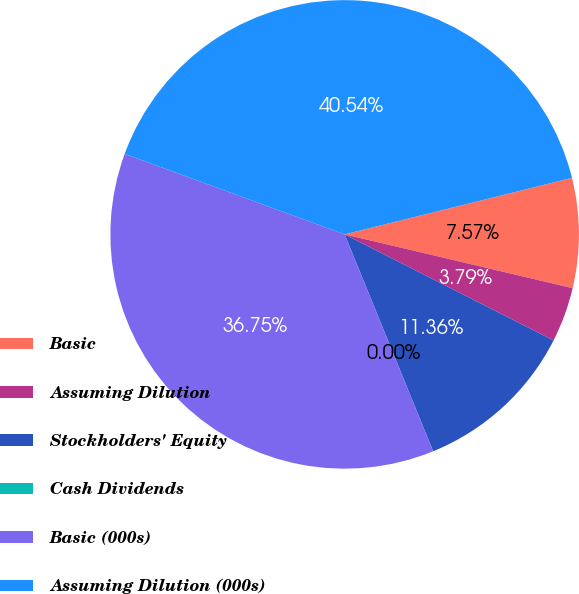Convert chart to OTSL. <chart><loc_0><loc_0><loc_500><loc_500><pie_chart><fcel>Basic<fcel>Assuming Dilution<fcel>Stockholders' Equity<fcel>Cash Dividends<fcel>Basic (000s)<fcel>Assuming Dilution (000s)<nl><fcel>7.57%<fcel>3.79%<fcel>11.36%<fcel>0.0%<fcel>36.75%<fcel>40.54%<nl></chart> 